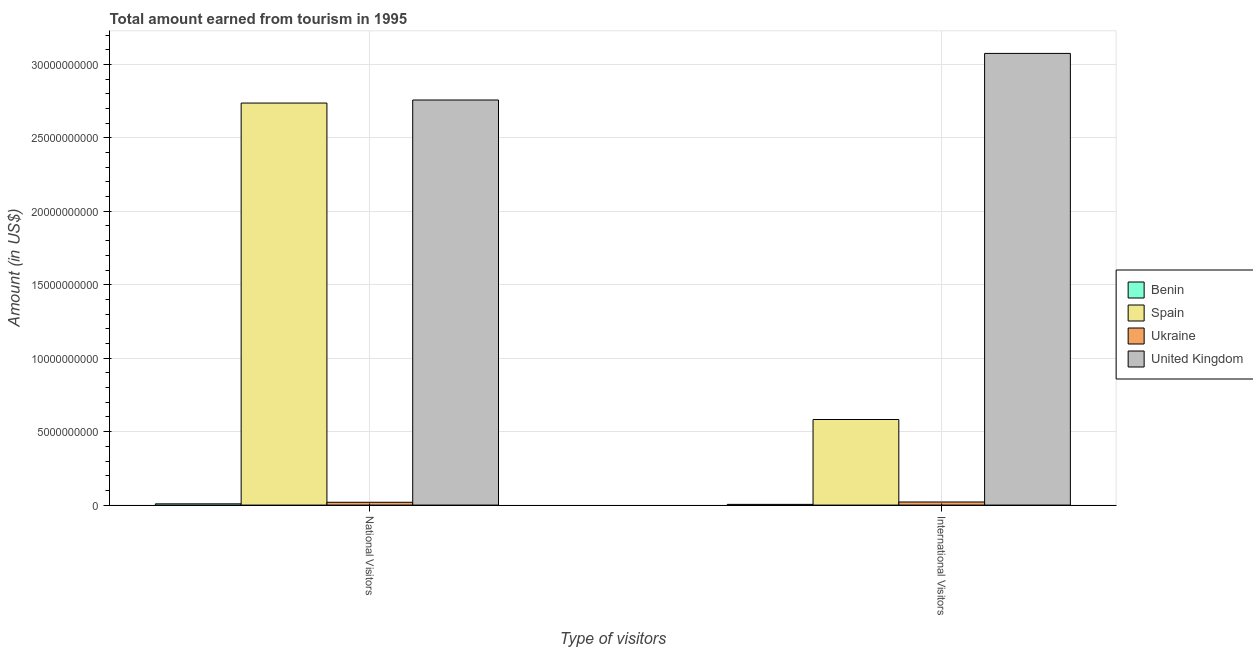How many different coloured bars are there?
Provide a succinct answer. 4. What is the label of the 2nd group of bars from the left?
Your response must be concise. International Visitors. What is the amount earned from international visitors in Benin?
Keep it short and to the point. 4.80e+07. Across all countries, what is the maximum amount earned from national visitors?
Make the answer very short. 2.76e+1. Across all countries, what is the minimum amount earned from international visitors?
Offer a terse response. 4.80e+07. In which country was the amount earned from international visitors maximum?
Provide a short and direct response. United Kingdom. In which country was the amount earned from national visitors minimum?
Give a very brief answer. Benin. What is the total amount earned from international visitors in the graph?
Keep it short and to the point. 3.68e+1. What is the difference between the amount earned from national visitors in Ukraine and that in Spain?
Give a very brief answer. -2.72e+1. What is the difference between the amount earned from international visitors in Benin and the amount earned from national visitors in United Kingdom?
Your answer should be compact. -2.75e+1. What is the average amount earned from national visitors per country?
Your response must be concise. 1.38e+1. What is the difference between the amount earned from international visitors and amount earned from national visitors in Spain?
Provide a succinct answer. -2.15e+1. What is the ratio of the amount earned from national visitors in Benin to that in Spain?
Provide a succinct answer. 0. In how many countries, is the amount earned from national visitors greater than the average amount earned from national visitors taken over all countries?
Your response must be concise. 2. What does the 2nd bar from the right in National Visitors represents?
Your response must be concise. Ukraine. How many countries are there in the graph?
Keep it short and to the point. 4. What is the difference between two consecutive major ticks on the Y-axis?
Provide a succinct answer. 5.00e+09. Are the values on the major ticks of Y-axis written in scientific E-notation?
Offer a very short reply. No. Does the graph contain any zero values?
Keep it short and to the point. No. How many legend labels are there?
Keep it short and to the point. 4. How are the legend labels stacked?
Give a very brief answer. Vertical. What is the title of the graph?
Offer a terse response. Total amount earned from tourism in 1995. What is the label or title of the X-axis?
Offer a very short reply. Type of visitors. What is the label or title of the Y-axis?
Offer a very short reply. Amount (in US$). What is the Amount (in US$) in Benin in National Visitors?
Your answer should be compact. 8.50e+07. What is the Amount (in US$) in Spain in National Visitors?
Ensure brevity in your answer.  2.74e+1. What is the Amount (in US$) of Ukraine in National Visitors?
Keep it short and to the point. 1.91e+08. What is the Amount (in US$) in United Kingdom in National Visitors?
Your response must be concise. 2.76e+1. What is the Amount (in US$) of Benin in International Visitors?
Give a very brief answer. 4.80e+07. What is the Amount (in US$) in Spain in International Visitors?
Provide a succinct answer. 5.83e+09. What is the Amount (in US$) in Ukraine in International Visitors?
Your answer should be very brief. 2.10e+08. What is the Amount (in US$) of United Kingdom in International Visitors?
Offer a terse response. 3.07e+1. Across all Type of visitors, what is the maximum Amount (in US$) in Benin?
Provide a short and direct response. 8.50e+07. Across all Type of visitors, what is the maximum Amount (in US$) of Spain?
Provide a succinct answer. 2.74e+1. Across all Type of visitors, what is the maximum Amount (in US$) in Ukraine?
Give a very brief answer. 2.10e+08. Across all Type of visitors, what is the maximum Amount (in US$) of United Kingdom?
Your answer should be compact. 3.07e+1. Across all Type of visitors, what is the minimum Amount (in US$) in Benin?
Give a very brief answer. 4.80e+07. Across all Type of visitors, what is the minimum Amount (in US$) in Spain?
Ensure brevity in your answer.  5.83e+09. Across all Type of visitors, what is the minimum Amount (in US$) of Ukraine?
Make the answer very short. 1.91e+08. Across all Type of visitors, what is the minimum Amount (in US$) of United Kingdom?
Give a very brief answer. 2.76e+1. What is the total Amount (in US$) in Benin in the graph?
Keep it short and to the point. 1.33e+08. What is the total Amount (in US$) in Spain in the graph?
Give a very brief answer. 3.32e+1. What is the total Amount (in US$) in Ukraine in the graph?
Offer a very short reply. 4.01e+08. What is the total Amount (in US$) in United Kingdom in the graph?
Provide a short and direct response. 5.83e+1. What is the difference between the Amount (in US$) in Benin in National Visitors and that in International Visitors?
Give a very brief answer. 3.70e+07. What is the difference between the Amount (in US$) in Spain in National Visitors and that in International Visitors?
Provide a succinct answer. 2.15e+1. What is the difference between the Amount (in US$) in Ukraine in National Visitors and that in International Visitors?
Your response must be concise. -1.90e+07. What is the difference between the Amount (in US$) of United Kingdom in National Visitors and that in International Visitors?
Keep it short and to the point. -3.17e+09. What is the difference between the Amount (in US$) of Benin in National Visitors and the Amount (in US$) of Spain in International Visitors?
Your answer should be very brief. -5.74e+09. What is the difference between the Amount (in US$) in Benin in National Visitors and the Amount (in US$) in Ukraine in International Visitors?
Your response must be concise. -1.25e+08. What is the difference between the Amount (in US$) in Benin in National Visitors and the Amount (in US$) in United Kingdom in International Visitors?
Your answer should be compact. -3.07e+1. What is the difference between the Amount (in US$) in Spain in National Visitors and the Amount (in US$) in Ukraine in International Visitors?
Offer a very short reply. 2.72e+1. What is the difference between the Amount (in US$) of Spain in National Visitors and the Amount (in US$) of United Kingdom in International Visitors?
Your answer should be compact. -3.38e+09. What is the difference between the Amount (in US$) in Ukraine in National Visitors and the Amount (in US$) in United Kingdom in International Visitors?
Your answer should be very brief. -3.06e+1. What is the average Amount (in US$) of Benin per Type of visitors?
Ensure brevity in your answer.  6.65e+07. What is the average Amount (in US$) of Spain per Type of visitors?
Ensure brevity in your answer.  1.66e+1. What is the average Amount (in US$) in Ukraine per Type of visitors?
Your answer should be compact. 2.00e+08. What is the average Amount (in US$) of United Kingdom per Type of visitors?
Your answer should be very brief. 2.92e+1. What is the difference between the Amount (in US$) of Benin and Amount (in US$) of Spain in National Visitors?
Provide a succinct answer. -2.73e+1. What is the difference between the Amount (in US$) in Benin and Amount (in US$) in Ukraine in National Visitors?
Offer a very short reply. -1.06e+08. What is the difference between the Amount (in US$) of Benin and Amount (in US$) of United Kingdom in National Visitors?
Offer a very short reply. -2.75e+1. What is the difference between the Amount (in US$) in Spain and Amount (in US$) in Ukraine in National Visitors?
Give a very brief answer. 2.72e+1. What is the difference between the Amount (in US$) in Spain and Amount (in US$) in United Kingdom in National Visitors?
Keep it short and to the point. -2.08e+08. What is the difference between the Amount (in US$) in Ukraine and Amount (in US$) in United Kingdom in National Visitors?
Give a very brief answer. -2.74e+1. What is the difference between the Amount (in US$) in Benin and Amount (in US$) in Spain in International Visitors?
Provide a succinct answer. -5.78e+09. What is the difference between the Amount (in US$) of Benin and Amount (in US$) of Ukraine in International Visitors?
Offer a terse response. -1.62e+08. What is the difference between the Amount (in US$) in Benin and Amount (in US$) in United Kingdom in International Visitors?
Offer a terse response. -3.07e+1. What is the difference between the Amount (in US$) in Spain and Amount (in US$) in Ukraine in International Visitors?
Your response must be concise. 5.62e+09. What is the difference between the Amount (in US$) of Spain and Amount (in US$) of United Kingdom in International Visitors?
Make the answer very short. -2.49e+1. What is the difference between the Amount (in US$) in Ukraine and Amount (in US$) in United Kingdom in International Visitors?
Offer a very short reply. -3.05e+1. What is the ratio of the Amount (in US$) in Benin in National Visitors to that in International Visitors?
Provide a short and direct response. 1.77. What is the ratio of the Amount (in US$) of Spain in National Visitors to that in International Visitors?
Make the answer very short. 4.7. What is the ratio of the Amount (in US$) in Ukraine in National Visitors to that in International Visitors?
Ensure brevity in your answer.  0.91. What is the ratio of the Amount (in US$) in United Kingdom in National Visitors to that in International Visitors?
Keep it short and to the point. 0.9. What is the difference between the highest and the second highest Amount (in US$) of Benin?
Your answer should be compact. 3.70e+07. What is the difference between the highest and the second highest Amount (in US$) of Spain?
Provide a succinct answer. 2.15e+1. What is the difference between the highest and the second highest Amount (in US$) of Ukraine?
Ensure brevity in your answer.  1.90e+07. What is the difference between the highest and the second highest Amount (in US$) in United Kingdom?
Your response must be concise. 3.17e+09. What is the difference between the highest and the lowest Amount (in US$) of Benin?
Make the answer very short. 3.70e+07. What is the difference between the highest and the lowest Amount (in US$) of Spain?
Your answer should be very brief. 2.15e+1. What is the difference between the highest and the lowest Amount (in US$) in Ukraine?
Ensure brevity in your answer.  1.90e+07. What is the difference between the highest and the lowest Amount (in US$) in United Kingdom?
Ensure brevity in your answer.  3.17e+09. 